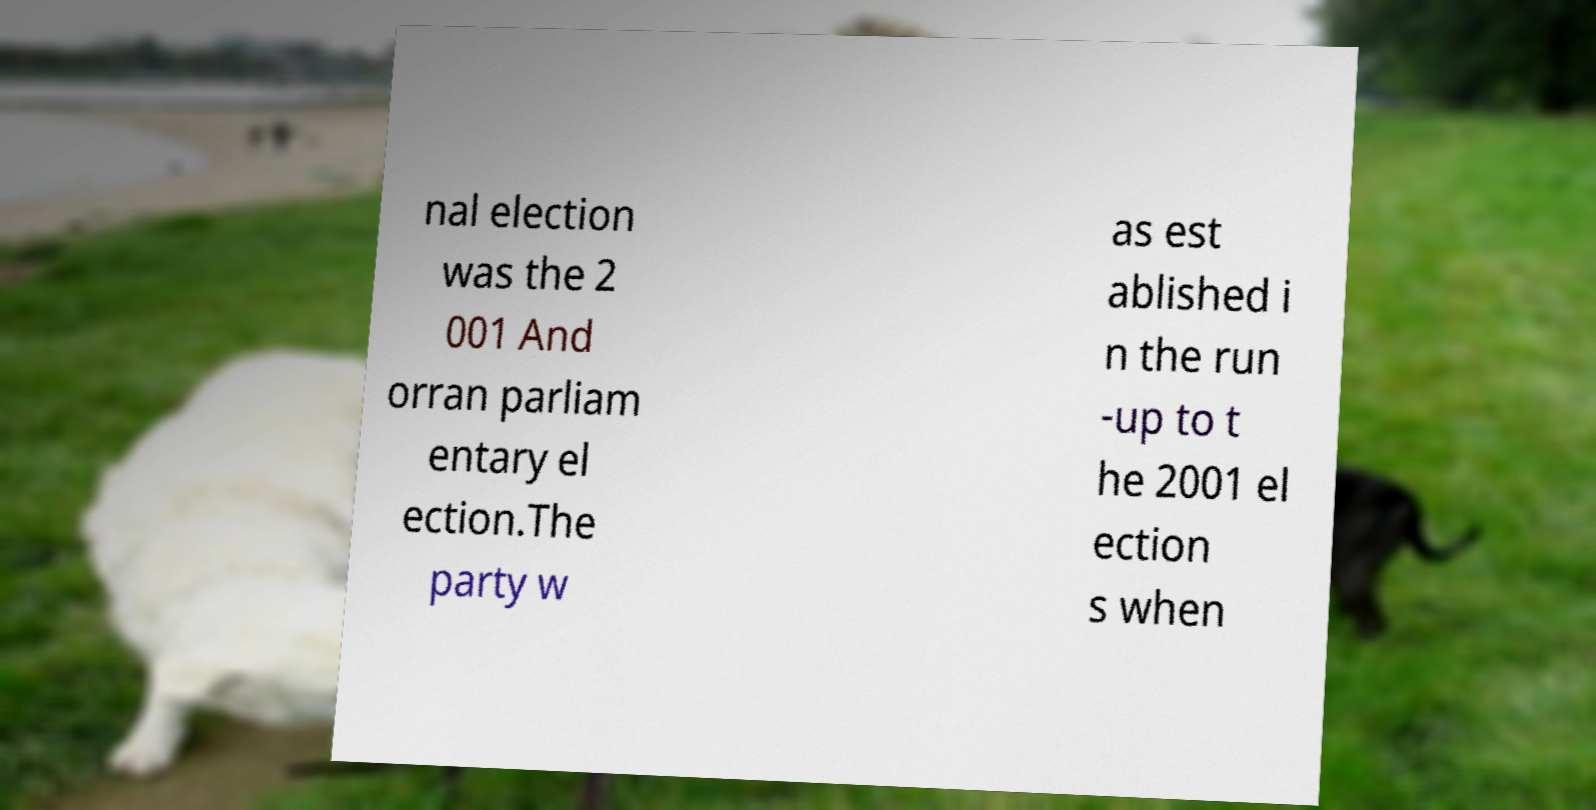Please read and relay the text visible in this image. What does it say? nal election was the 2 001 And orran parliam entary el ection.The party w as est ablished i n the run -up to t he 2001 el ection s when 